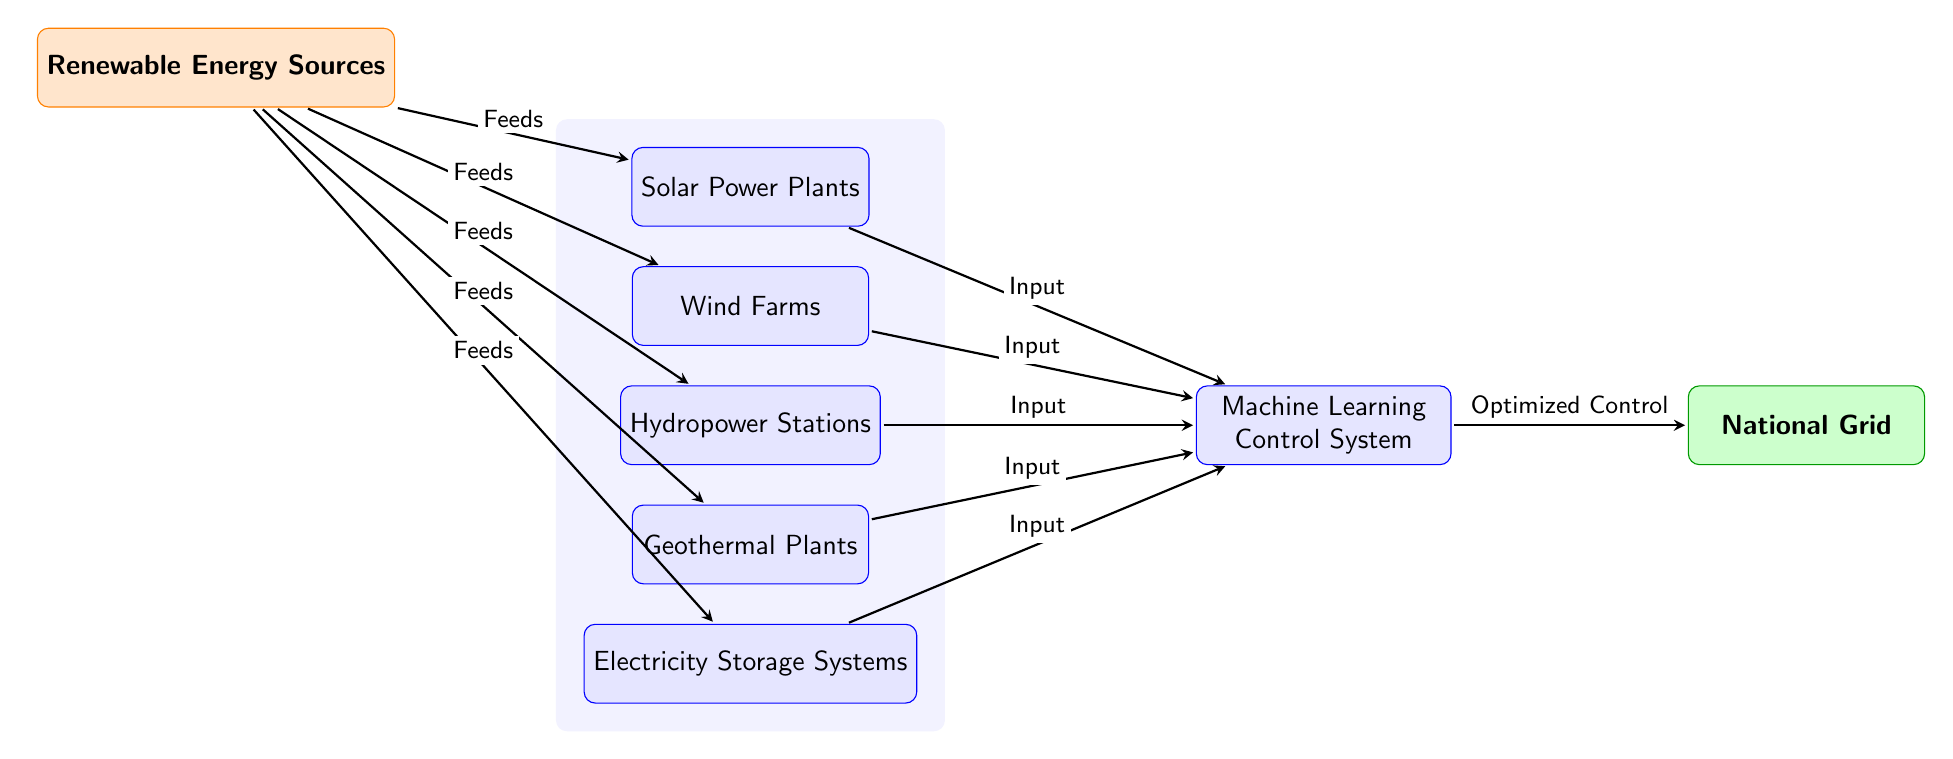What are the renewable energy sources listed in the diagram? The diagram specifically mentions five renewable energy sources: Solar Power Plants, Wind Farms, Hydropower Stations, Geothermal Plants, and Electricity Storage Systems. These sources are depicted as processes connected to the input node labeled "Renewable Energy Sources."
Answer: Solar Power Plants, Wind Farms, Hydropower Stations, Geothermal Plants, Electricity Storage Systems How many processes are involved in the integration? There are five distinct processes identified in the diagram, including the Machine Learning Control System, which aids in optimizing control for these renewable sources. The processes are Solar Power Plants, Wind Farms, Hydropower Stations, Geothermal Plants, and Electricity Storage Systems.
Answer: Five What is the purpose of the Machine Learning Control System in the diagram? The Machine Learning Control System is designed to take inputs from all renewable energy sources and provide optimized control to the National Grid. This is illustrated by the arrow leading from the Machine Learning node to the National Grid output.
Answer: Optimized Control Which renewable energy source feeds directly into the Machine Learning Control System? Each of the five renewable energy sources, namely Solar Power Plants, Wind Farms, Hydropower Stations, Geothermal Plants, and Electricity Storage Systems, feeds directly into the Machine Learning Control System. This is indicated by the arrows connecting these sources to the ML node.
Answer: All of them What is the output of this machine learning diagram? The output of the diagram is the National Grid, which receives optimized control signals from the Machine Learning Control System as a result of processing data from various renewable energy sources. This is signified by the arrow leading from the ML system to the grid.
Answer: National Grid How does electricity storage relate to other inputs? Electricity Storage Systems are included as one of the renewable energy sources that feed data into the Machine Learning Control System. It plays a crucial role in balancing and optimizing energy supply, representing the flexibility needed in the grid.
Answer: They feed data into the ML system 